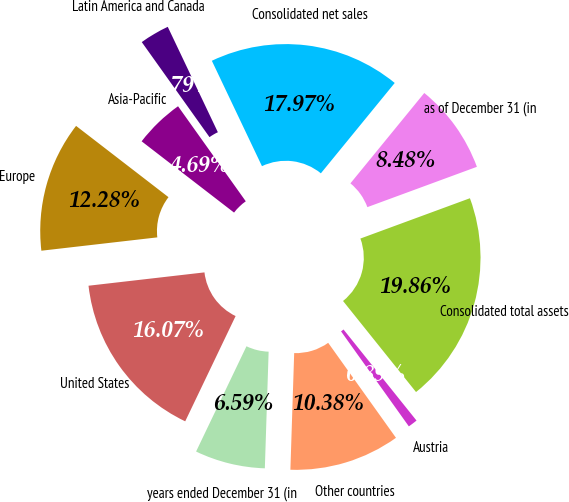Convert chart to OTSL. <chart><loc_0><loc_0><loc_500><loc_500><pie_chart><fcel>years ended December 31 (in<fcel>United States<fcel>Europe<fcel>Asia-Pacific<fcel>Latin America and Canada<fcel>Consolidated net sales<fcel>as of December 31 (in<fcel>Consolidated total assets<fcel>Austria<fcel>Other countries<nl><fcel>6.59%<fcel>16.07%<fcel>12.28%<fcel>4.69%<fcel>2.79%<fcel>17.97%<fcel>8.48%<fcel>19.86%<fcel>0.89%<fcel>10.38%<nl></chart> 